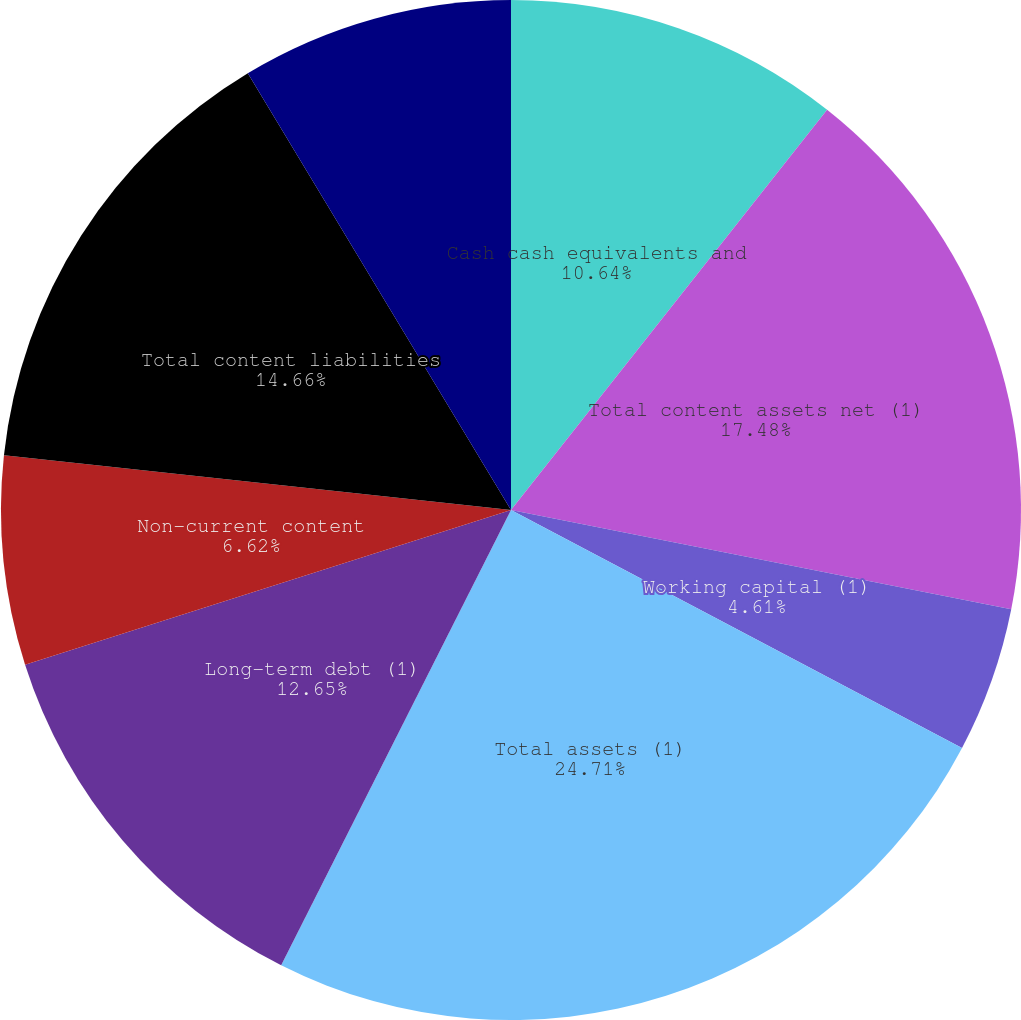Convert chart. <chart><loc_0><loc_0><loc_500><loc_500><pie_chart><fcel>Cash cash equivalents and<fcel>Total content assets net (1)<fcel>Working capital (1)<fcel>Total assets (1)<fcel>Long-term debt (1)<fcel>Non-current content<fcel>Total content liabilities<fcel>Total stockholders' equity<nl><fcel>10.64%<fcel>17.48%<fcel>4.61%<fcel>24.71%<fcel>12.65%<fcel>6.62%<fcel>14.66%<fcel>8.63%<nl></chart> 